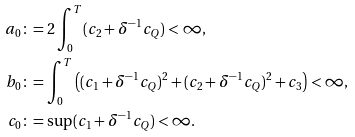Convert formula to latex. <formula><loc_0><loc_0><loc_500><loc_500>a _ { 0 } & \colon = 2 \int _ { 0 } ^ { T } ( c _ { 2 } + \delta ^ { - 1 } c _ { Q } ) < \infty , \\ b _ { 0 } & \colon = \int _ { 0 } ^ { T } \left ( ( c _ { 1 } + \delta ^ { - 1 } c _ { Q } ) ^ { 2 } + ( c _ { 2 } + \delta ^ { - 1 } c _ { Q } ) ^ { 2 } + c _ { 3 } \right ) < \infty , \\ c _ { 0 } & \colon = \sup ( c _ { 1 } + \delta ^ { - 1 } c _ { Q } ) < \infty .</formula> 